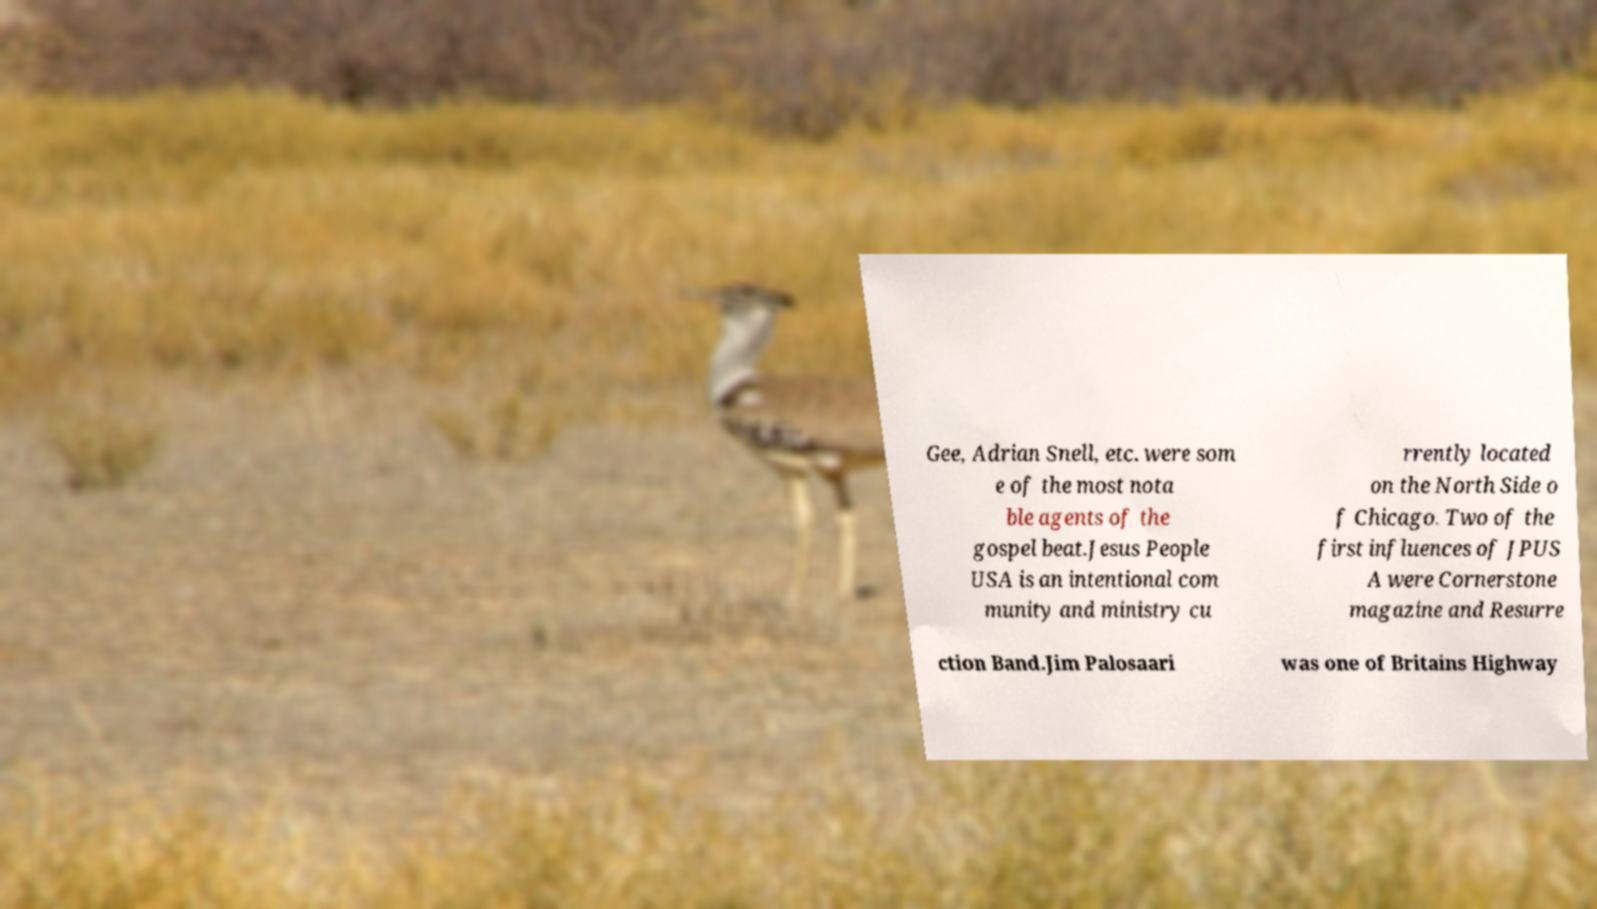Can you read and provide the text displayed in the image?This photo seems to have some interesting text. Can you extract and type it out for me? Gee, Adrian Snell, etc. were som e of the most nota ble agents of the gospel beat.Jesus People USA is an intentional com munity and ministry cu rrently located on the North Side o f Chicago. Two of the first influences of JPUS A were Cornerstone magazine and Resurre ction Band.Jim Palosaari was one of Britains Highway 